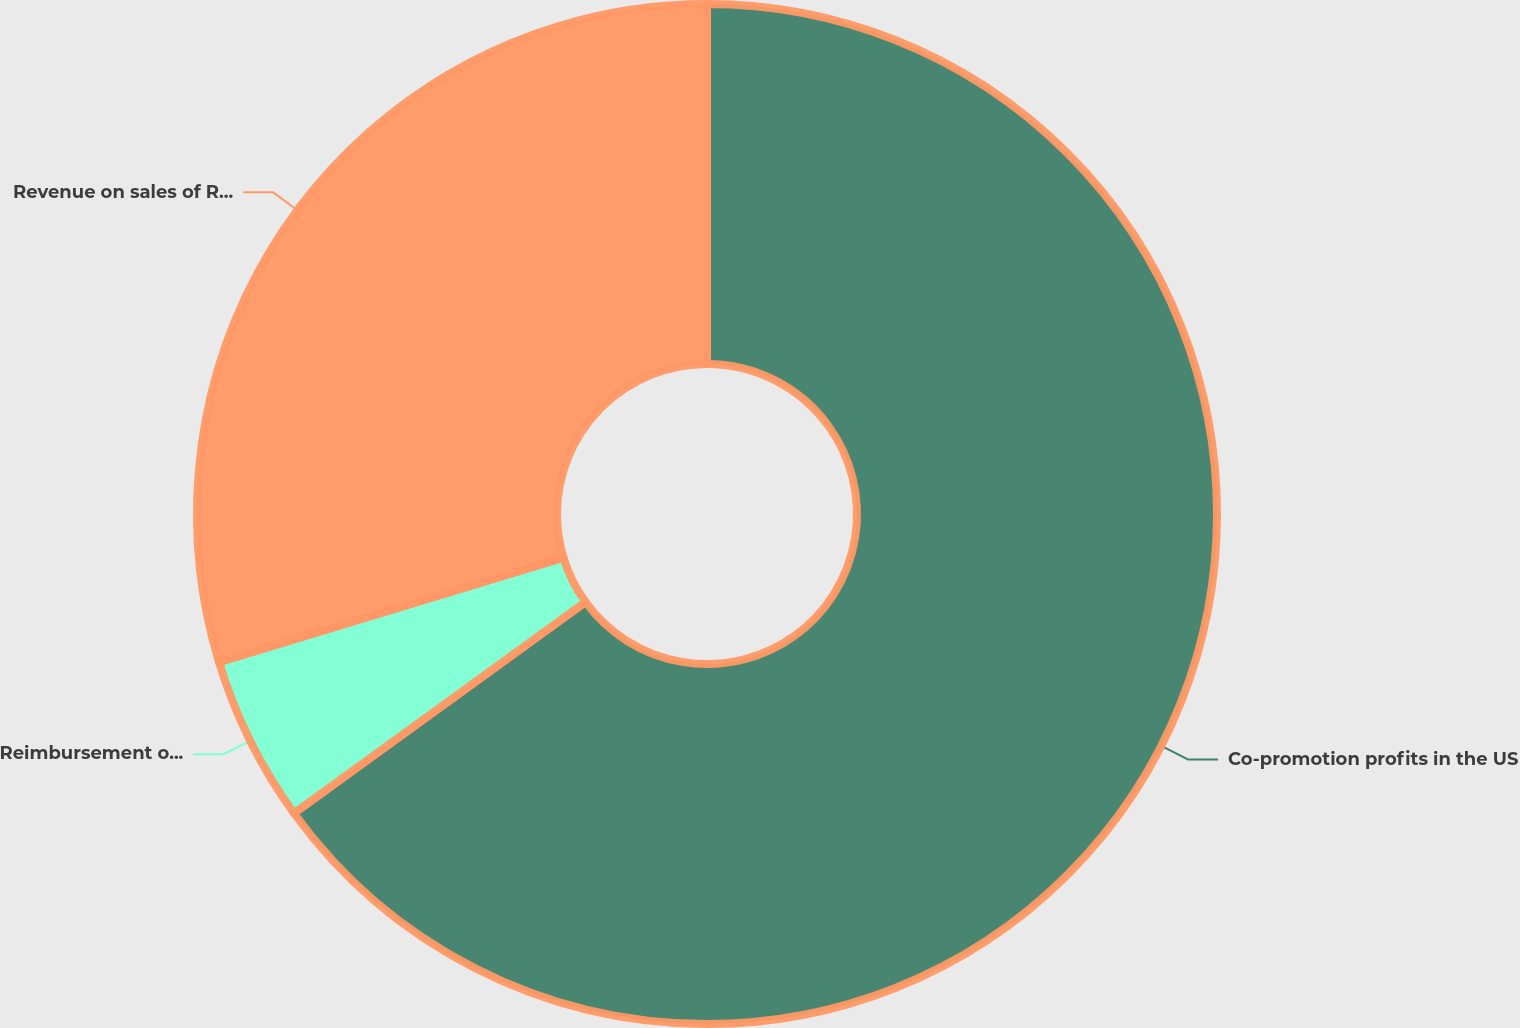<chart> <loc_0><loc_0><loc_500><loc_500><pie_chart><fcel>Co-promotion profits in the US<fcel>Reimbursement of selling and<fcel>Revenue on sales of RITUXAN<nl><fcel>65.02%<fcel>5.29%<fcel>29.69%<nl></chart> 